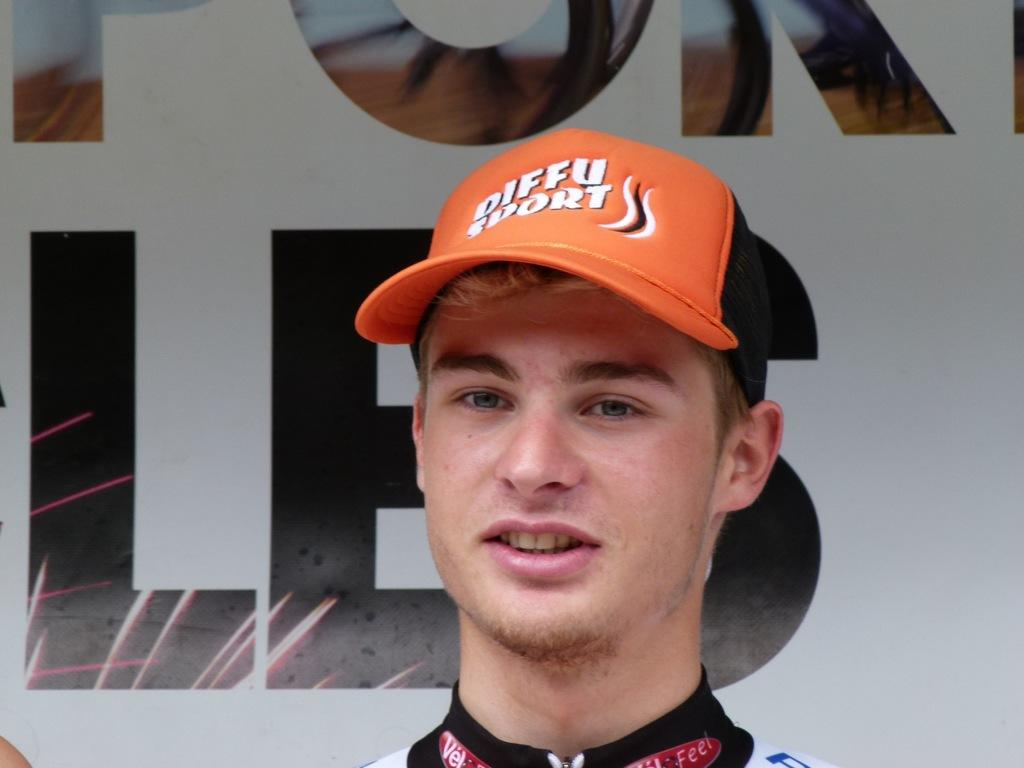<image>
Present a compact description of the photo's key features. A man in a Diffu Sport cap stands in front of a big sign. 